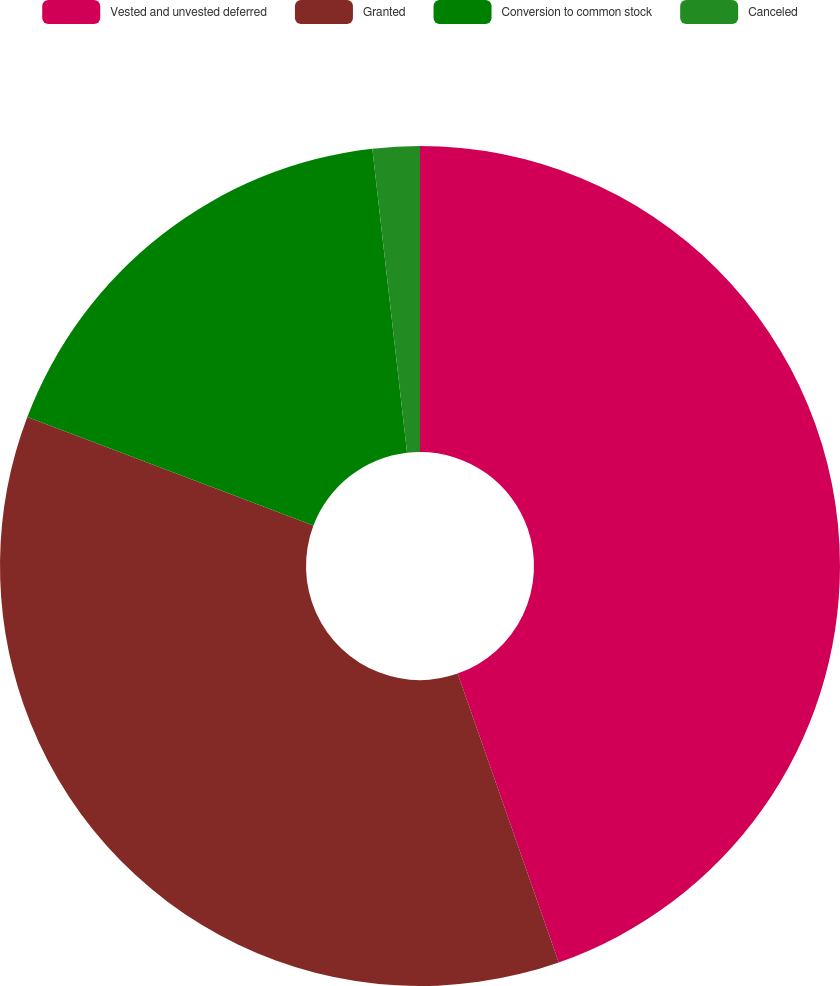Convert chart to OTSL. <chart><loc_0><loc_0><loc_500><loc_500><pie_chart><fcel>Vested and unvested deferred<fcel>Granted<fcel>Conversion to common stock<fcel>Canceled<nl><fcel>44.64%<fcel>36.13%<fcel>17.42%<fcel>1.81%<nl></chart> 